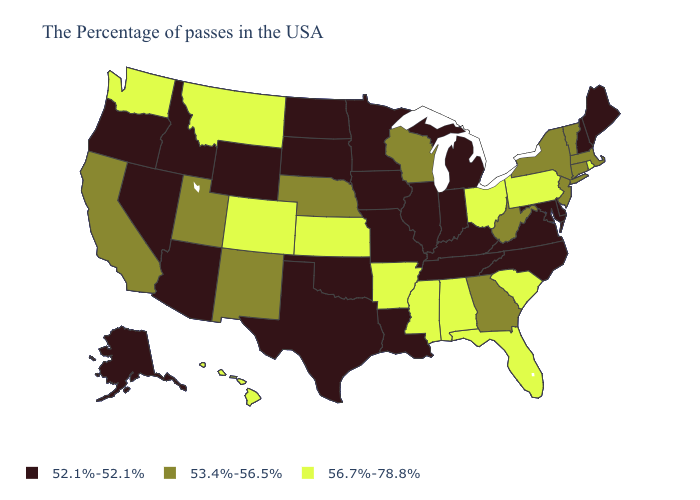Among the states that border Arizona , which have the highest value?
Write a very short answer. Colorado. Does Hawaii have the same value as Michigan?
Give a very brief answer. No. Name the states that have a value in the range 56.7%-78.8%?
Concise answer only. Rhode Island, Pennsylvania, South Carolina, Ohio, Florida, Alabama, Mississippi, Arkansas, Kansas, Colorado, Montana, Washington, Hawaii. What is the highest value in the USA?
Quick response, please. 56.7%-78.8%. What is the value of Wyoming?
Short answer required. 52.1%-52.1%. Does Iowa have the highest value in the USA?
Keep it brief. No. What is the value of Maryland?
Concise answer only. 52.1%-52.1%. Name the states that have a value in the range 56.7%-78.8%?
Be succinct. Rhode Island, Pennsylvania, South Carolina, Ohio, Florida, Alabama, Mississippi, Arkansas, Kansas, Colorado, Montana, Washington, Hawaii. Name the states that have a value in the range 53.4%-56.5%?
Answer briefly. Massachusetts, Vermont, Connecticut, New York, New Jersey, West Virginia, Georgia, Wisconsin, Nebraska, New Mexico, Utah, California. Does the first symbol in the legend represent the smallest category?
Answer briefly. Yes. Name the states that have a value in the range 52.1%-52.1%?
Be succinct. Maine, New Hampshire, Delaware, Maryland, Virginia, North Carolina, Michigan, Kentucky, Indiana, Tennessee, Illinois, Louisiana, Missouri, Minnesota, Iowa, Oklahoma, Texas, South Dakota, North Dakota, Wyoming, Arizona, Idaho, Nevada, Oregon, Alaska. How many symbols are there in the legend?
Write a very short answer. 3. What is the value of Kentucky?
Write a very short answer. 52.1%-52.1%. Does the map have missing data?
Be succinct. No. Name the states that have a value in the range 52.1%-52.1%?
Answer briefly. Maine, New Hampshire, Delaware, Maryland, Virginia, North Carolina, Michigan, Kentucky, Indiana, Tennessee, Illinois, Louisiana, Missouri, Minnesota, Iowa, Oklahoma, Texas, South Dakota, North Dakota, Wyoming, Arizona, Idaho, Nevada, Oregon, Alaska. 